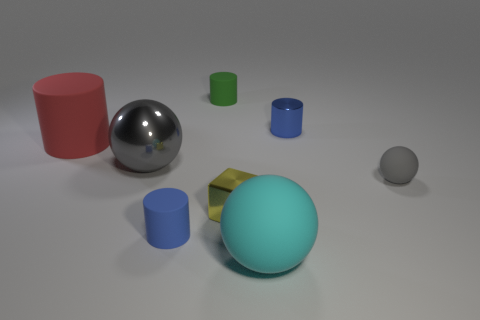Add 1 spheres. How many objects exist? 9 Subtract all spheres. How many objects are left? 5 Subtract 0 brown spheres. How many objects are left? 8 Subtract all tiny gray balls. Subtract all green rubber things. How many objects are left? 6 Add 1 red matte things. How many red matte things are left? 2 Add 7 yellow matte objects. How many yellow matte objects exist? 7 